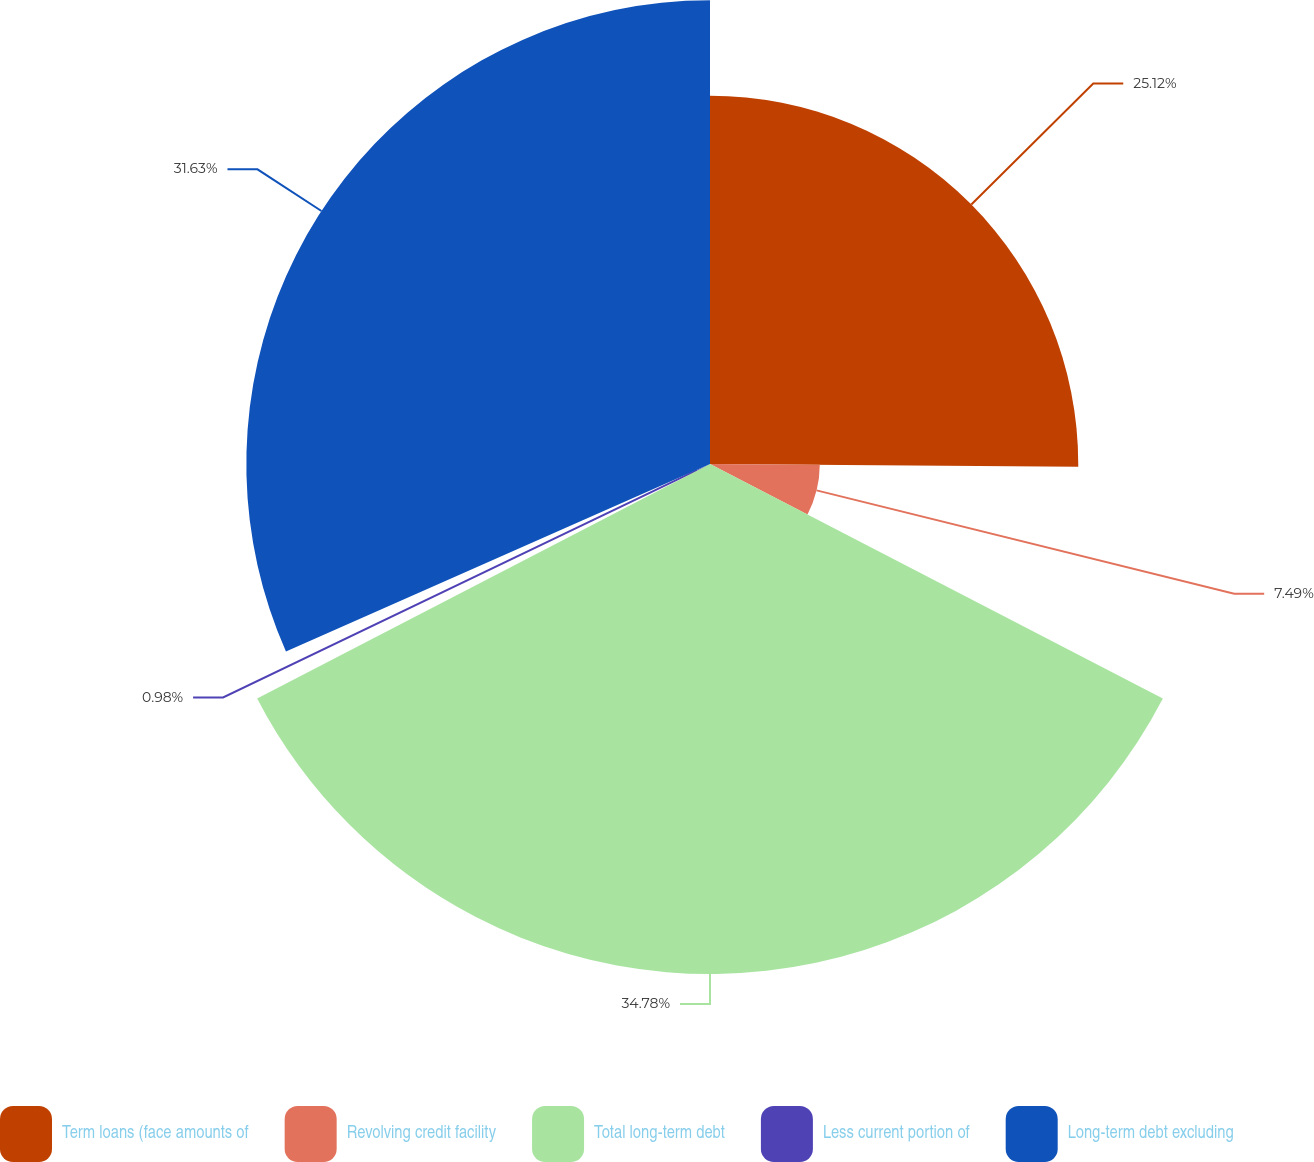<chart> <loc_0><loc_0><loc_500><loc_500><pie_chart><fcel>Term loans (face amounts of<fcel>Revolving credit facility<fcel>Total long-term debt<fcel>Less current portion of<fcel>Long-term debt excluding<nl><fcel>25.12%<fcel>7.49%<fcel>34.79%<fcel>0.98%<fcel>31.63%<nl></chart> 